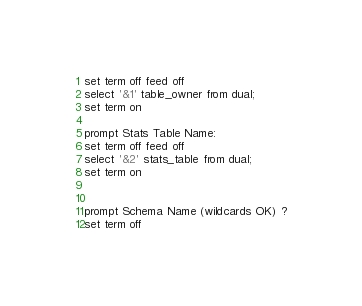Convert code to text. <code><loc_0><loc_0><loc_500><loc_500><_SQL_>set term off feed off
select '&1' table_owner from dual;
set term on

prompt Stats Table Name:
set term off feed off
select '&2' stats_table from dual;
set term on


prompt Schema Name (wildcards OK) ?
set term off</code> 